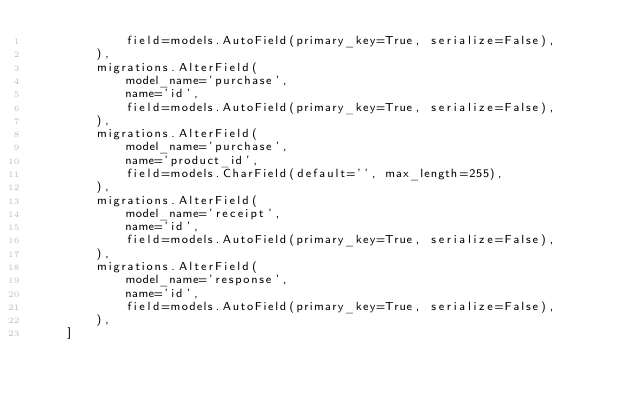<code> <loc_0><loc_0><loc_500><loc_500><_Python_>            field=models.AutoField(primary_key=True, serialize=False),
        ),
        migrations.AlterField(
            model_name='purchase',
            name='id',
            field=models.AutoField(primary_key=True, serialize=False),
        ),
        migrations.AlterField(
            model_name='purchase',
            name='product_id',
            field=models.CharField(default='', max_length=255),
        ),
        migrations.AlterField(
            model_name='receipt',
            name='id',
            field=models.AutoField(primary_key=True, serialize=False),
        ),
        migrations.AlterField(
            model_name='response',
            name='id',
            field=models.AutoField(primary_key=True, serialize=False),
        ),
    ]
</code> 